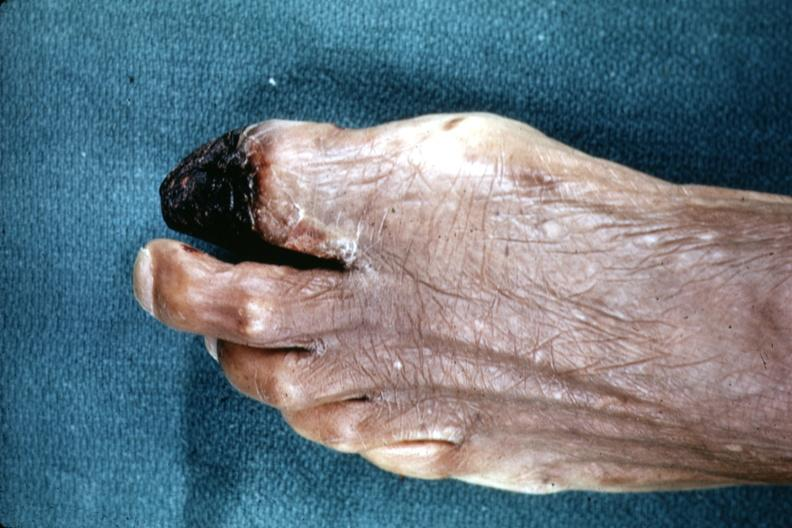re extremities present?
Answer the question using a single word or phrase. Yes 